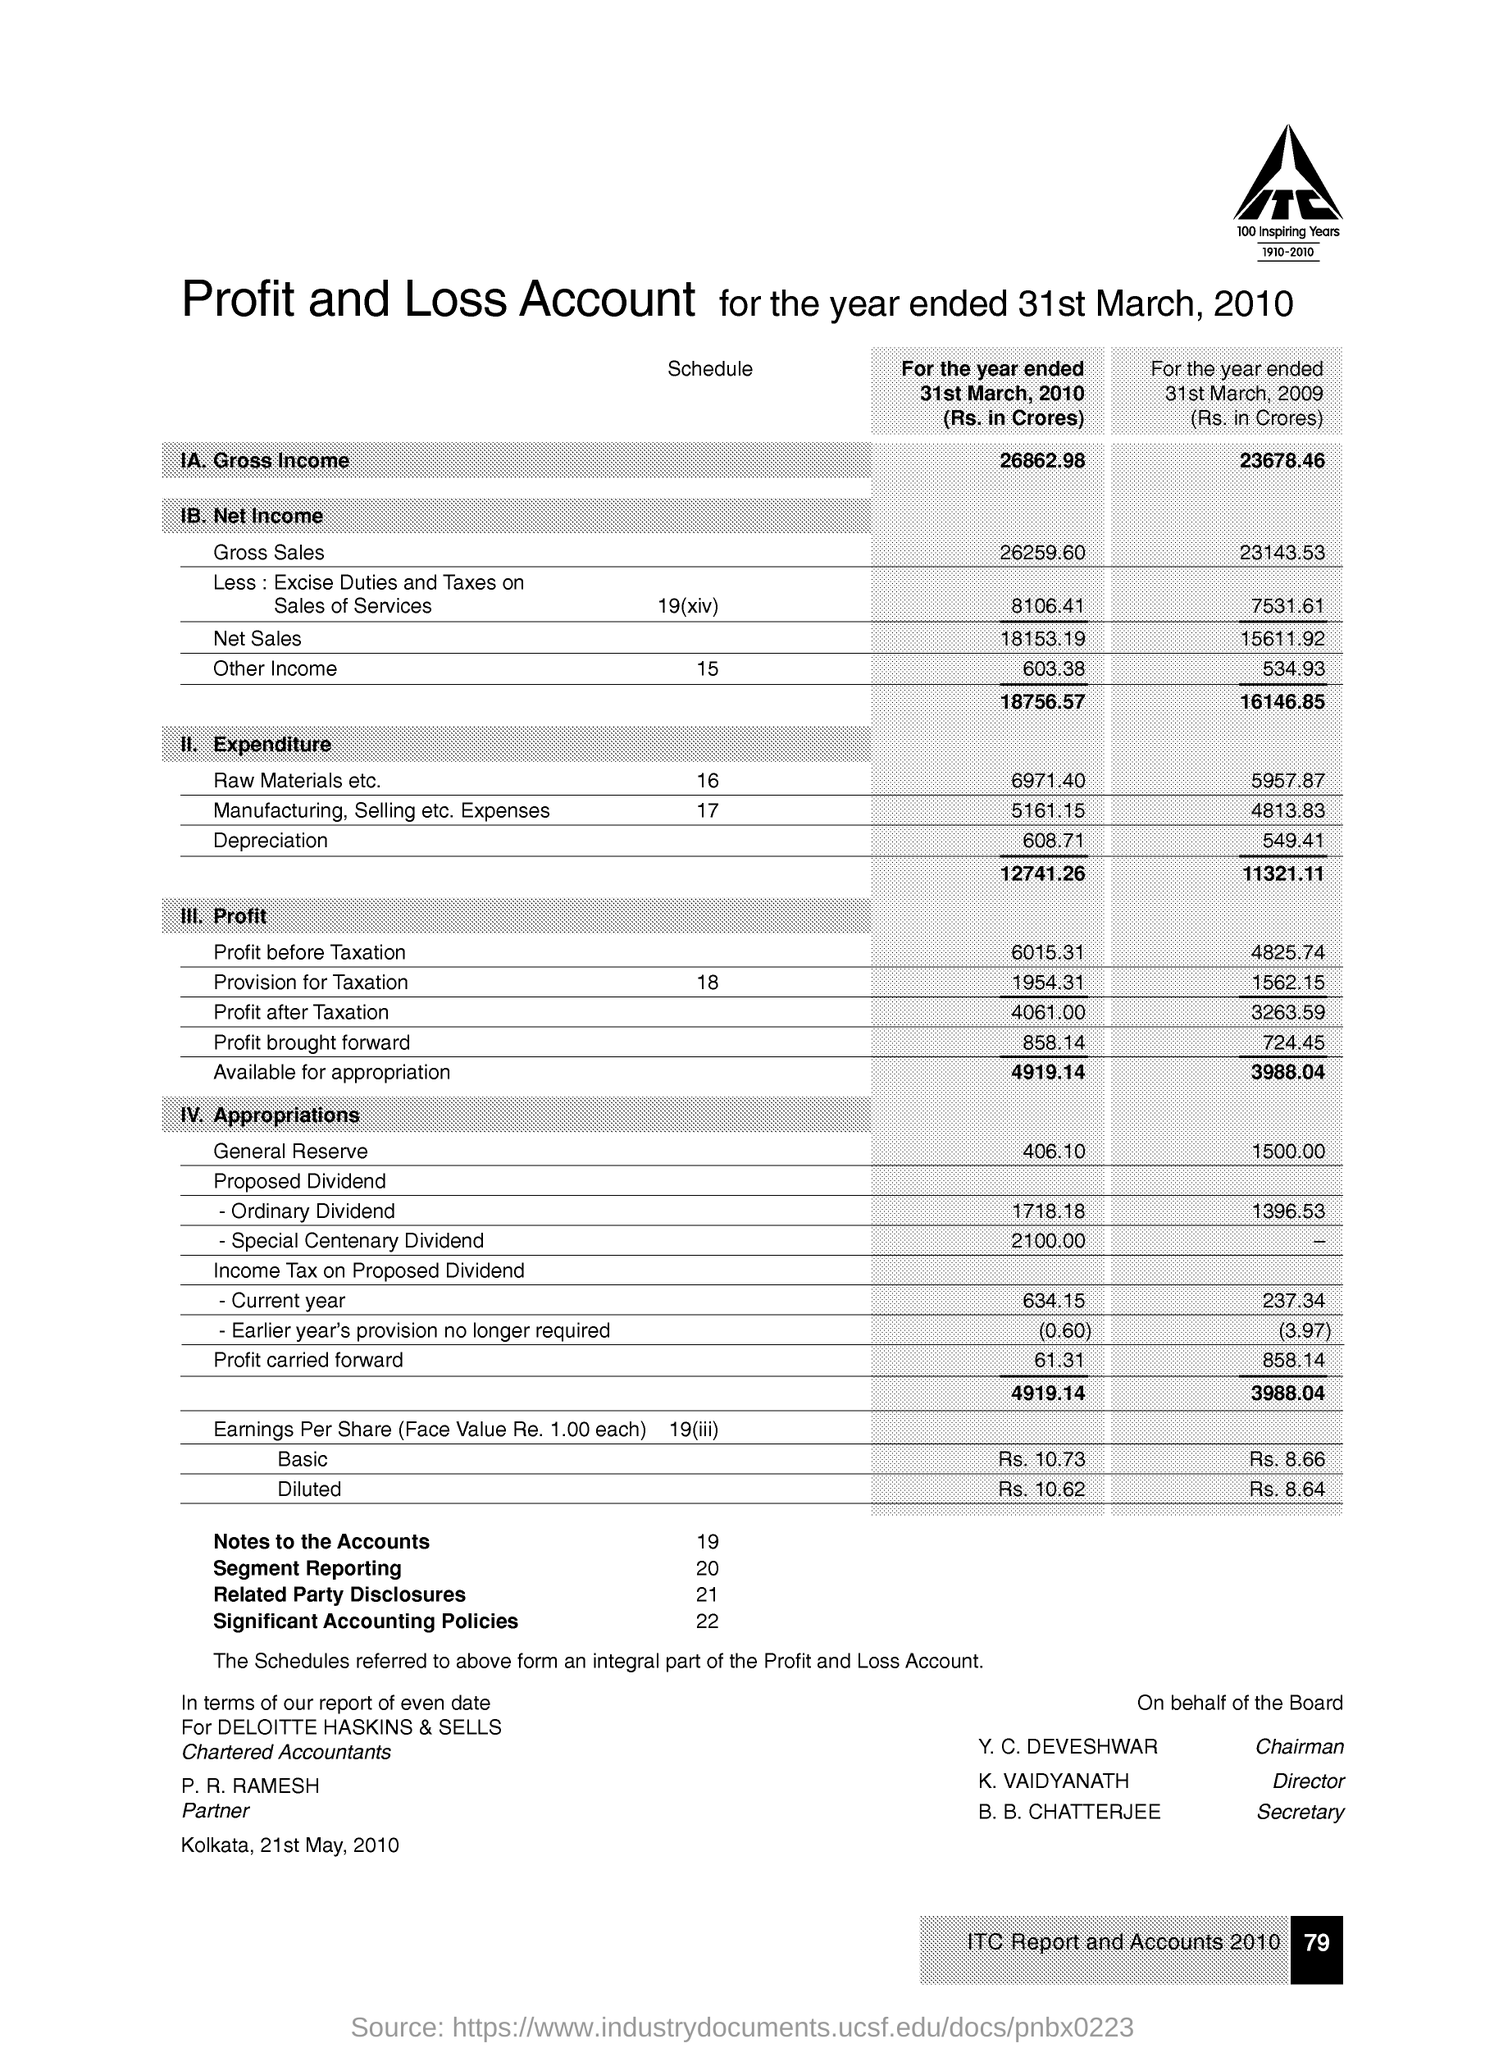What is the number of Segment Reporting?
Make the answer very short. 20. What is the number of Related party disclosures?
Your response must be concise. 21. What is the number of notes to the accounts?
Offer a terse response. 19. What is the number of Significant accounting policies?
Keep it short and to the point. 22. 